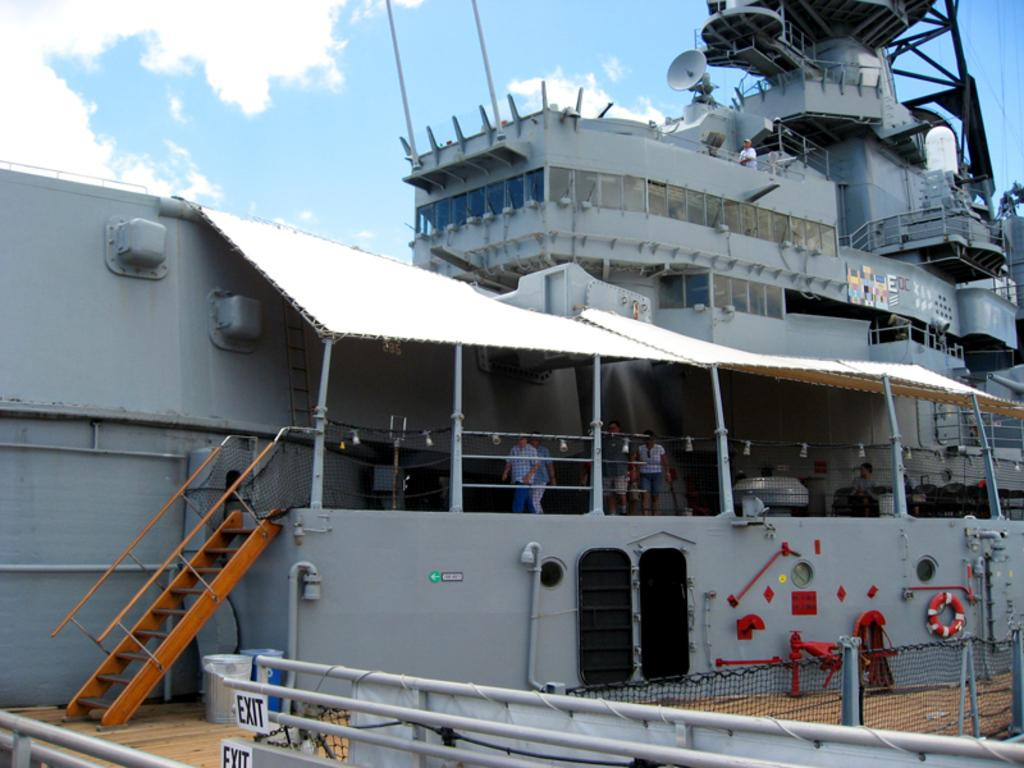<image>
Share a concise interpretation of the image provided. A military battle ship is being toured by civilians. 